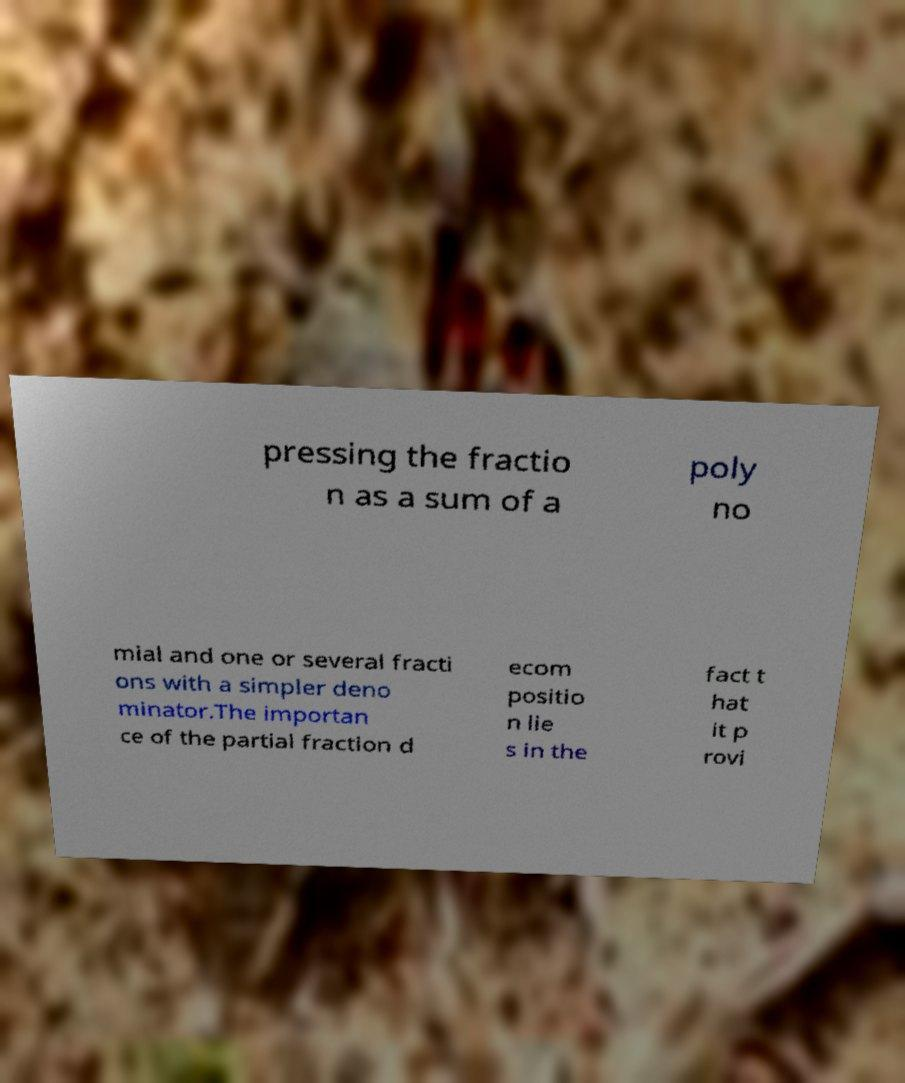Can you read and provide the text displayed in the image?This photo seems to have some interesting text. Can you extract and type it out for me? pressing the fractio n as a sum of a poly no mial and one or several fracti ons with a simpler deno minator.The importan ce of the partial fraction d ecom positio n lie s in the fact t hat it p rovi 